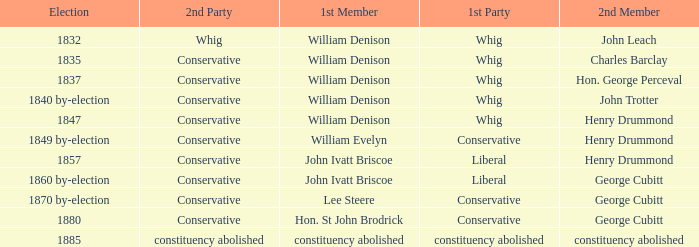Which party's 1st member is William Denison in the election of 1832? Whig. Can you parse all the data within this table? {'header': ['Election', '2nd Party', '1st Member', '1st Party', '2nd Member'], 'rows': [['1832', 'Whig', 'William Denison', 'Whig', 'John Leach'], ['1835', 'Conservative', 'William Denison', 'Whig', 'Charles Barclay'], ['1837', 'Conservative', 'William Denison', 'Whig', 'Hon. George Perceval'], ['1840 by-election', 'Conservative', 'William Denison', 'Whig', 'John Trotter'], ['1847', 'Conservative', 'William Denison', 'Whig', 'Henry Drummond'], ['1849 by-election', 'Conservative', 'William Evelyn', 'Conservative', 'Henry Drummond'], ['1857', 'Conservative', 'John Ivatt Briscoe', 'Liberal', 'Henry Drummond'], ['1860 by-election', 'Conservative', 'John Ivatt Briscoe', 'Liberal', 'George Cubitt'], ['1870 by-election', 'Conservative', 'Lee Steere', 'Conservative', 'George Cubitt'], ['1880', 'Conservative', 'Hon. St John Brodrick', 'Conservative', 'George Cubitt'], ['1885', 'constituency abolished', 'constituency abolished', 'constituency abolished', 'constituency abolished']]} 